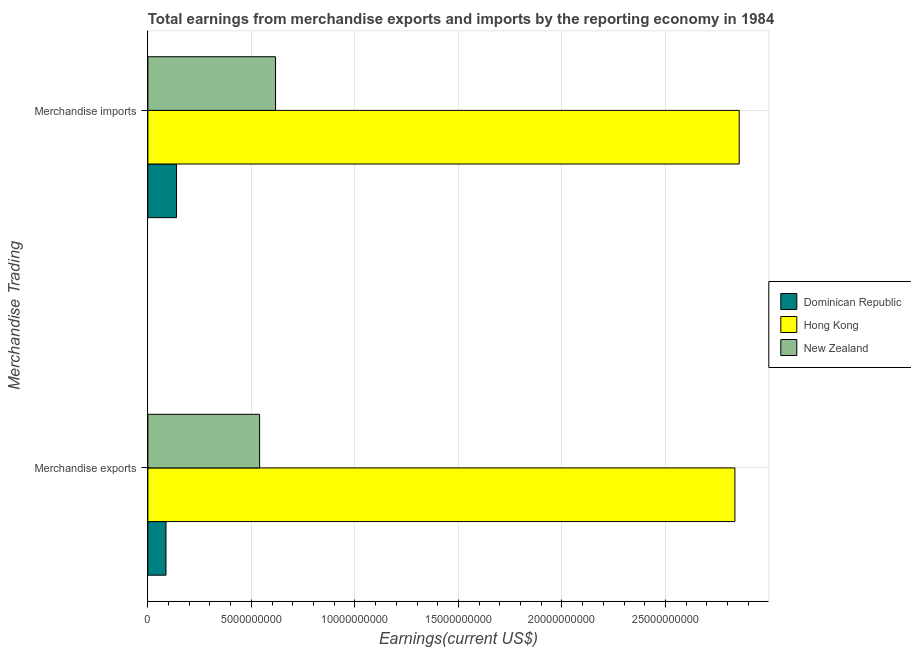Are the number of bars per tick equal to the number of legend labels?
Your response must be concise. Yes. How many bars are there on the 1st tick from the top?
Keep it short and to the point. 3. How many bars are there on the 2nd tick from the bottom?
Make the answer very short. 3. What is the label of the 2nd group of bars from the top?
Your response must be concise. Merchandise exports. What is the earnings from merchandise exports in Dominican Republic?
Make the answer very short. 8.75e+08. Across all countries, what is the maximum earnings from merchandise exports?
Offer a terse response. 2.84e+1. Across all countries, what is the minimum earnings from merchandise exports?
Make the answer very short. 8.75e+08. In which country was the earnings from merchandise exports maximum?
Offer a very short reply. Hong Kong. In which country was the earnings from merchandise exports minimum?
Your answer should be compact. Dominican Republic. What is the total earnings from merchandise imports in the graph?
Provide a succinct answer. 3.61e+1. What is the difference between the earnings from merchandise exports in Dominican Republic and that in Hong Kong?
Provide a succinct answer. -2.75e+1. What is the difference between the earnings from merchandise imports in Hong Kong and the earnings from merchandise exports in New Zealand?
Ensure brevity in your answer.  2.32e+1. What is the average earnings from merchandise imports per country?
Ensure brevity in your answer.  1.20e+1. What is the difference between the earnings from merchandise exports and earnings from merchandise imports in New Zealand?
Your answer should be compact. -7.71e+08. In how many countries, is the earnings from merchandise exports greater than 25000000000 US$?
Provide a short and direct response. 1. What is the ratio of the earnings from merchandise exports in New Zealand to that in Dominican Republic?
Offer a terse response. 6.17. Is the earnings from merchandise exports in Dominican Republic less than that in New Zealand?
Provide a succinct answer. Yes. What does the 1st bar from the top in Merchandise exports represents?
Your answer should be compact. New Zealand. What does the 3rd bar from the bottom in Merchandise imports represents?
Keep it short and to the point. New Zealand. Are all the bars in the graph horizontal?
Make the answer very short. Yes. How many countries are there in the graph?
Your answer should be compact. 3. Are the values on the major ticks of X-axis written in scientific E-notation?
Your answer should be very brief. No. Does the graph contain grids?
Give a very brief answer. Yes. Where does the legend appear in the graph?
Keep it short and to the point. Center right. How many legend labels are there?
Your response must be concise. 3. What is the title of the graph?
Your answer should be very brief. Total earnings from merchandise exports and imports by the reporting economy in 1984. Does "Cameroon" appear as one of the legend labels in the graph?
Offer a terse response. No. What is the label or title of the X-axis?
Offer a terse response. Earnings(current US$). What is the label or title of the Y-axis?
Provide a succinct answer. Merchandise Trading. What is the Earnings(current US$) in Dominican Republic in Merchandise exports?
Offer a terse response. 8.75e+08. What is the Earnings(current US$) of Hong Kong in Merchandise exports?
Your answer should be very brief. 2.84e+1. What is the Earnings(current US$) in New Zealand in Merchandise exports?
Provide a succinct answer. 5.40e+09. What is the Earnings(current US$) in Dominican Republic in Merchandise imports?
Make the answer very short. 1.38e+09. What is the Earnings(current US$) of Hong Kong in Merchandise imports?
Your response must be concise. 2.86e+1. What is the Earnings(current US$) of New Zealand in Merchandise imports?
Your answer should be very brief. 6.17e+09. Across all Merchandise Trading, what is the maximum Earnings(current US$) in Dominican Republic?
Provide a short and direct response. 1.38e+09. Across all Merchandise Trading, what is the maximum Earnings(current US$) of Hong Kong?
Provide a succinct answer. 2.86e+1. Across all Merchandise Trading, what is the maximum Earnings(current US$) of New Zealand?
Ensure brevity in your answer.  6.17e+09. Across all Merchandise Trading, what is the minimum Earnings(current US$) in Dominican Republic?
Offer a very short reply. 8.75e+08. Across all Merchandise Trading, what is the minimum Earnings(current US$) of Hong Kong?
Keep it short and to the point. 2.84e+1. Across all Merchandise Trading, what is the minimum Earnings(current US$) of New Zealand?
Ensure brevity in your answer.  5.40e+09. What is the total Earnings(current US$) in Dominican Republic in the graph?
Provide a short and direct response. 2.26e+09. What is the total Earnings(current US$) of Hong Kong in the graph?
Your answer should be very brief. 5.69e+1. What is the total Earnings(current US$) in New Zealand in the graph?
Offer a terse response. 1.16e+1. What is the difference between the Earnings(current US$) in Dominican Republic in Merchandise exports and that in Merchandise imports?
Give a very brief answer. -5.08e+08. What is the difference between the Earnings(current US$) of Hong Kong in Merchandise exports and that in Merchandise imports?
Offer a very short reply. -2.09e+08. What is the difference between the Earnings(current US$) in New Zealand in Merchandise exports and that in Merchandise imports?
Keep it short and to the point. -7.71e+08. What is the difference between the Earnings(current US$) of Dominican Republic in Merchandise exports and the Earnings(current US$) of Hong Kong in Merchandise imports?
Your answer should be compact. -2.77e+1. What is the difference between the Earnings(current US$) of Dominican Republic in Merchandise exports and the Earnings(current US$) of New Zealand in Merchandise imports?
Your answer should be very brief. -5.29e+09. What is the difference between the Earnings(current US$) of Hong Kong in Merchandise exports and the Earnings(current US$) of New Zealand in Merchandise imports?
Keep it short and to the point. 2.22e+1. What is the average Earnings(current US$) in Dominican Republic per Merchandise Trading?
Your answer should be compact. 1.13e+09. What is the average Earnings(current US$) of Hong Kong per Merchandise Trading?
Your response must be concise. 2.85e+1. What is the average Earnings(current US$) in New Zealand per Merchandise Trading?
Make the answer very short. 5.78e+09. What is the difference between the Earnings(current US$) in Dominican Republic and Earnings(current US$) in Hong Kong in Merchandise exports?
Offer a terse response. -2.75e+1. What is the difference between the Earnings(current US$) of Dominican Republic and Earnings(current US$) of New Zealand in Merchandise exports?
Provide a succinct answer. -4.52e+09. What is the difference between the Earnings(current US$) of Hong Kong and Earnings(current US$) of New Zealand in Merchandise exports?
Keep it short and to the point. 2.30e+1. What is the difference between the Earnings(current US$) in Dominican Republic and Earnings(current US$) in Hong Kong in Merchandise imports?
Your answer should be compact. -2.72e+1. What is the difference between the Earnings(current US$) in Dominican Republic and Earnings(current US$) in New Zealand in Merchandise imports?
Your answer should be compact. -4.78e+09. What is the difference between the Earnings(current US$) of Hong Kong and Earnings(current US$) of New Zealand in Merchandise imports?
Your response must be concise. 2.24e+1. What is the ratio of the Earnings(current US$) of Dominican Republic in Merchandise exports to that in Merchandise imports?
Offer a very short reply. 0.63. What is the ratio of the Earnings(current US$) of Hong Kong in Merchandise exports to that in Merchandise imports?
Keep it short and to the point. 0.99. What is the ratio of the Earnings(current US$) in New Zealand in Merchandise exports to that in Merchandise imports?
Your answer should be very brief. 0.88. What is the difference between the highest and the second highest Earnings(current US$) of Dominican Republic?
Keep it short and to the point. 5.08e+08. What is the difference between the highest and the second highest Earnings(current US$) of Hong Kong?
Offer a very short reply. 2.09e+08. What is the difference between the highest and the second highest Earnings(current US$) of New Zealand?
Offer a terse response. 7.71e+08. What is the difference between the highest and the lowest Earnings(current US$) of Dominican Republic?
Your response must be concise. 5.08e+08. What is the difference between the highest and the lowest Earnings(current US$) of Hong Kong?
Make the answer very short. 2.09e+08. What is the difference between the highest and the lowest Earnings(current US$) in New Zealand?
Your answer should be compact. 7.71e+08. 